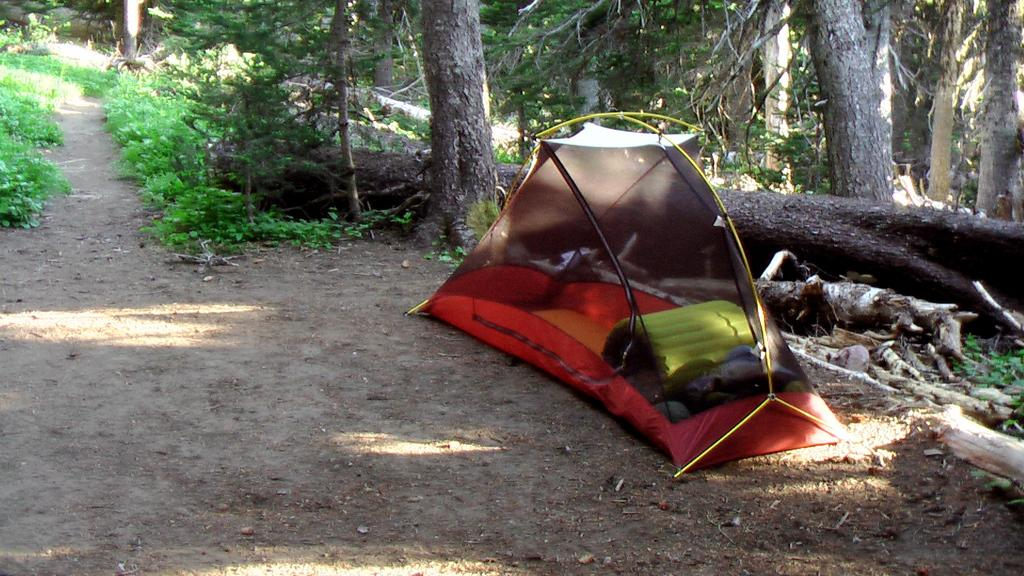What structure is visible in the image? There is a tent in the image. What can be found inside the tent? There are things inside the tent. What type of vegetation is visible in the background of the image? There are plants and trees in the background of the image. What type of leather material is used to make the crib in the image? There is no crib present in the image, so it is not possible to determine what type of leather material might be used. 